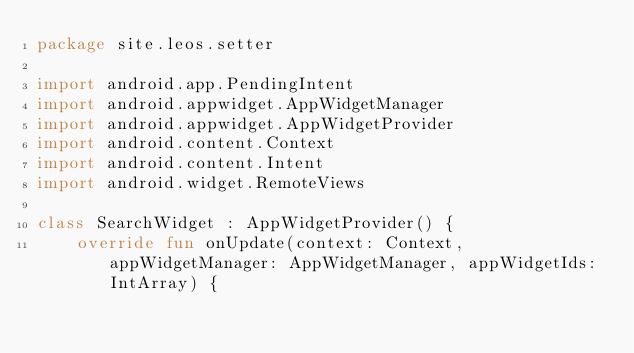Convert code to text. <code><loc_0><loc_0><loc_500><loc_500><_Kotlin_>package site.leos.setter

import android.app.PendingIntent
import android.appwidget.AppWidgetManager
import android.appwidget.AppWidgetProvider
import android.content.Context
import android.content.Intent
import android.widget.RemoteViews

class SearchWidget : AppWidgetProvider() {
    override fun onUpdate(context: Context, appWidgetManager: AppWidgetManager, appWidgetIds: IntArray) {</code> 